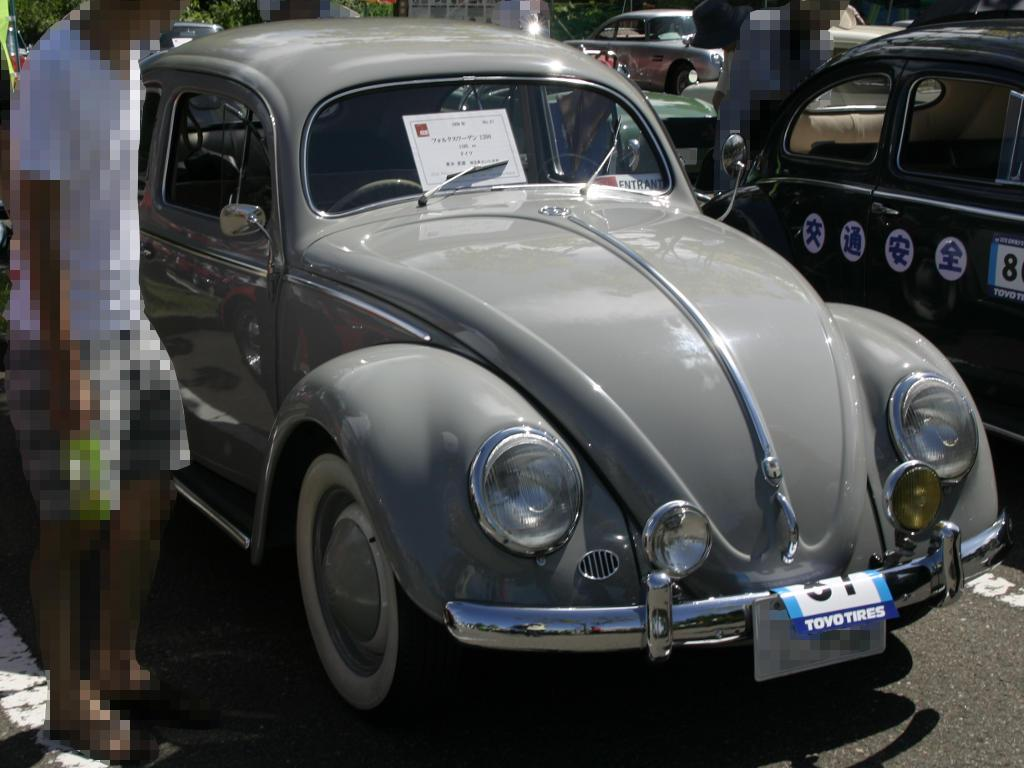What type of vehicles can be seen in the image? There are cars in the image. Who or what else is present in the image? There are people in the image. Where are the people located in the image? The people are on the road. What can be seen in the background of the image? There are trees at the top of the image. How would you describe the appearance of the people in the image? The people in the image appear blurred. What type of answer can be seen in the image? There is no answer present in the image; it features cars, people, and trees. What thrilling activity is the baby performing in the image? There is no baby present in the image, so no such activity can be observed. 